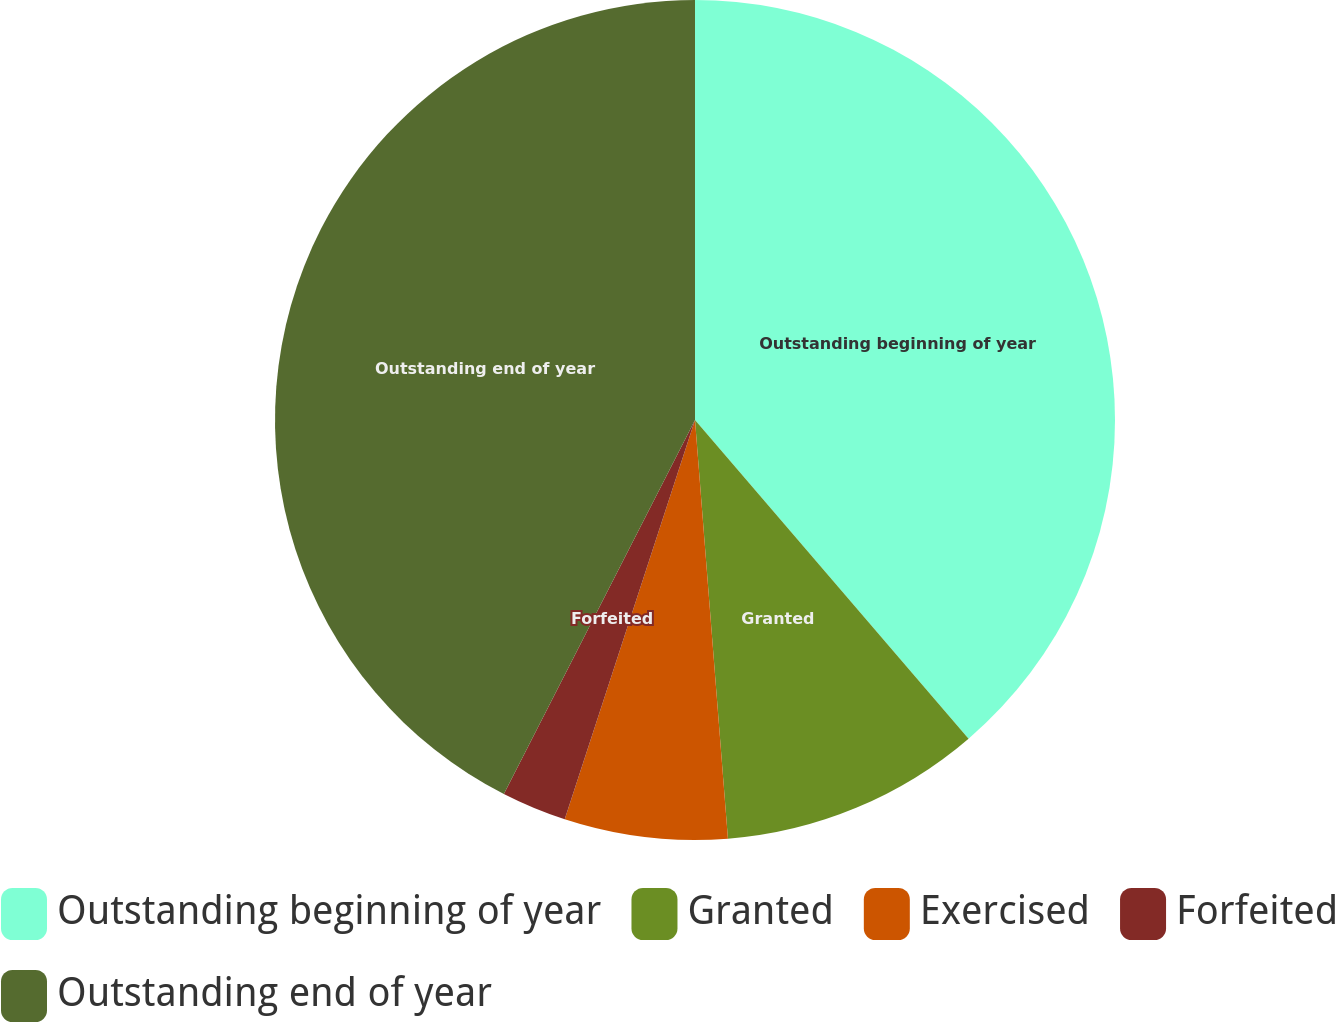<chart> <loc_0><loc_0><loc_500><loc_500><pie_chart><fcel>Outstanding beginning of year<fcel>Granted<fcel>Exercised<fcel>Forfeited<fcel>Outstanding end of year<nl><fcel>38.71%<fcel>10.04%<fcel>6.27%<fcel>2.5%<fcel>42.48%<nl></chart> 